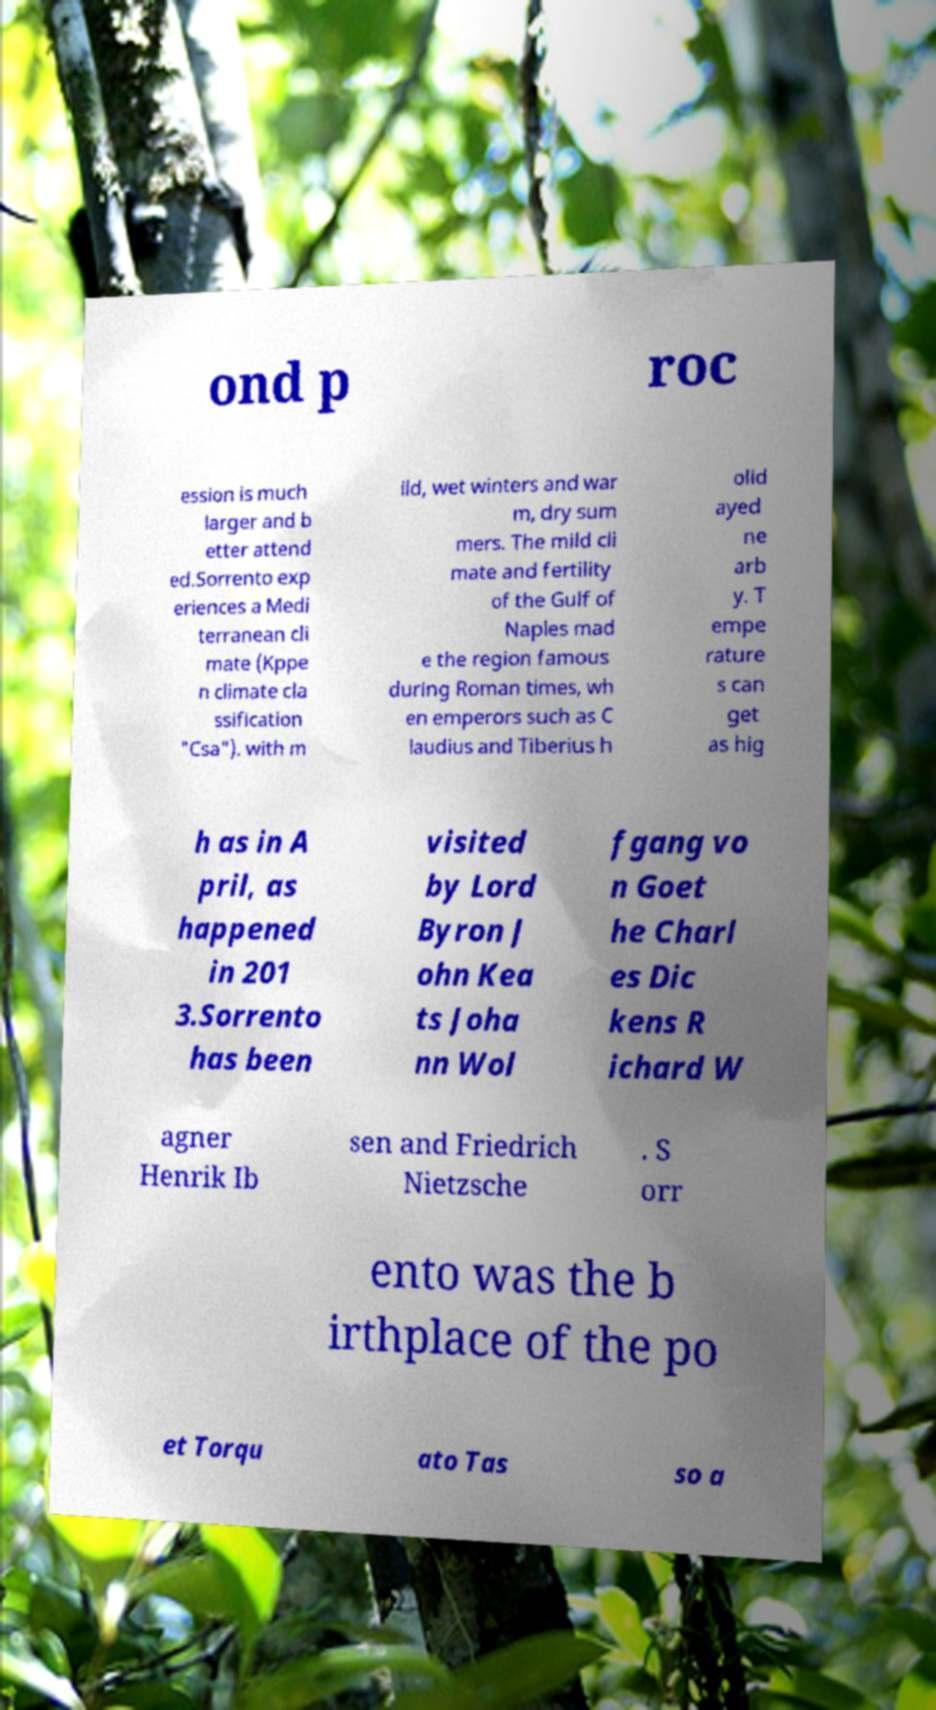Could you extract and type out the text from this image? ond p roc ession is much larger and b etter attend ed.Sorrento exp eriences a Medi terranean cli mate (Kppe n climate cla ssification "Csa"). with m ild, wet winters and war m, dry sum mers. The mild cli mate and fertility of the Gulf of Naples mad e the region famous during Roman times, wh en emperors such as C laudius and Tiberius h olid ayed ne arb y. T empe rature s can get as hig h as in A pril, as happened in 201 3.Sorrento has been visited by Lord Byron J ohn Kea ts Joha nn Wol fgang vo n Goet he Charl es Dic kens R ichard W agner Henrik Ib sen and Friedrich Nietzsche . S orr ento was the b irthplace of the po et Torqu ato Tas so a 